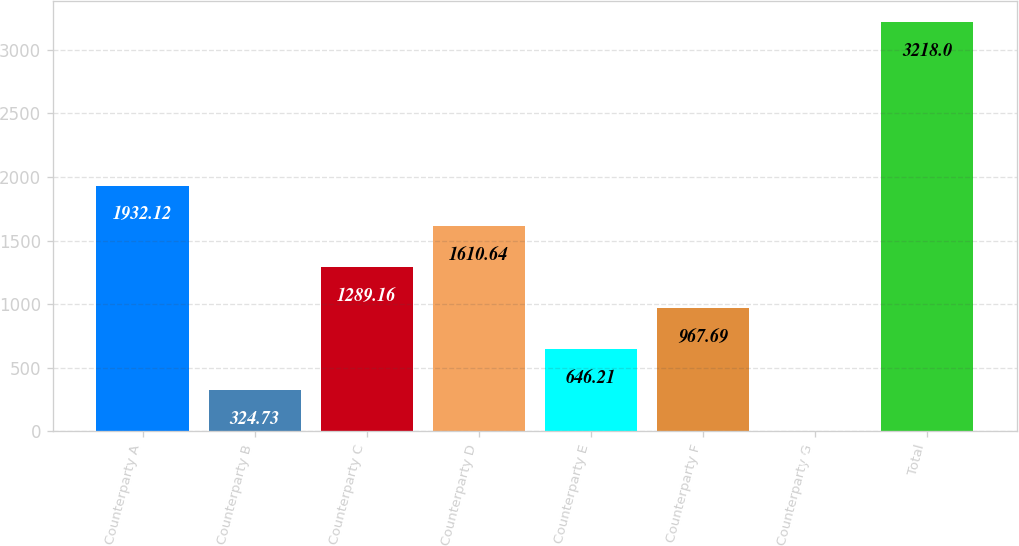<chart> <loc_0><loc_0><loc_500><loc_500><bar_chart><fcel>Counterparty A<fcel>Counterparty B<fcel>Counterparty C<fcel>Counterparty D<fcel>Counterparty E<fcel>Counterparty F<fcel>Counterparty G<fcel>Total<nl><fcel>1932.12<fcel>324.73<fcel>1289.16<fcel>1610.64<fcel>646.21<fcel>967.69<fcel>3.25<fcel>3218<nl></chart> 